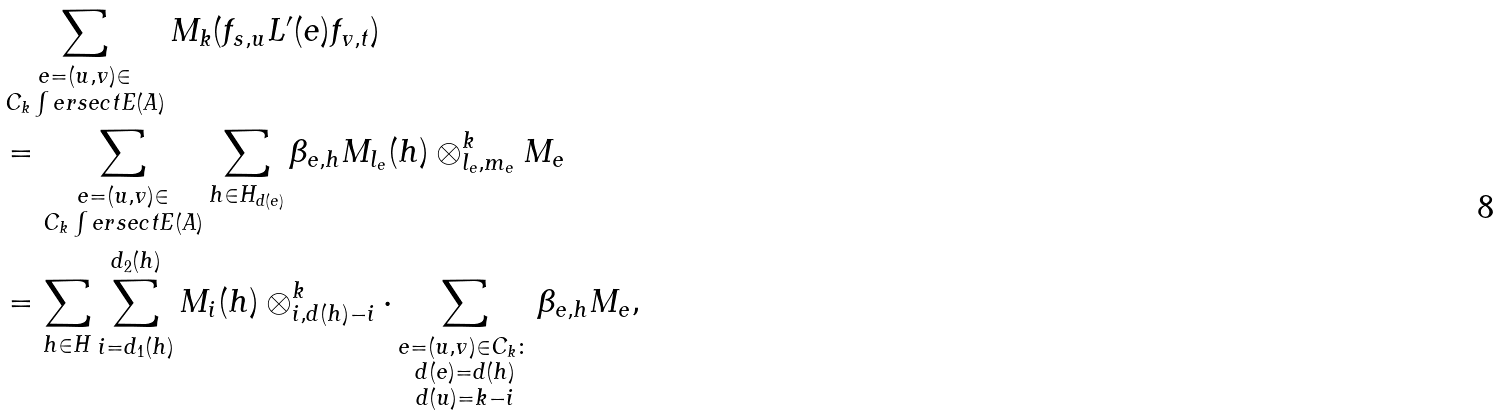Convert formula to latex. <formula><loc_0><loc_0><loc_500><loc_500>& \sum _ { \substack { e = ( u , v ) \in \\ C _ { k } \int e r s e c t E ( A ) } } M _ { k } ( f _ { s , u } L ^ { \prime } ( e ) f _ { v , t } ) \\ & = \sum _ { \substack { e = ( u , v ) \in \\ C _ { k } \int e r s e c t E ( A ) } } \sum _ { h \in H _ { d ( e ) } } \beta _ { e , h } M _ { l _ { e } } ( h ) \otimes _ { l _ { e } , m _ { e } } ^ { k } M _ { e } \\ & = \sum _ { h \in H } \sum _ { i = d _ { 1 } ( h ) } ^ { d _ { 2 } ( h ) } M _ { i } ( h ) \otimes _ { i , d ( h ) - i } ^ { k } \cdot \sum _ { \substack { e = ( u , v ) \in C _ { k } \colon \\ d ( e ) = d ( h ) \\ d ( u ) = k - i } } \beta _ { e , h } M _ { e } ,</formula> 